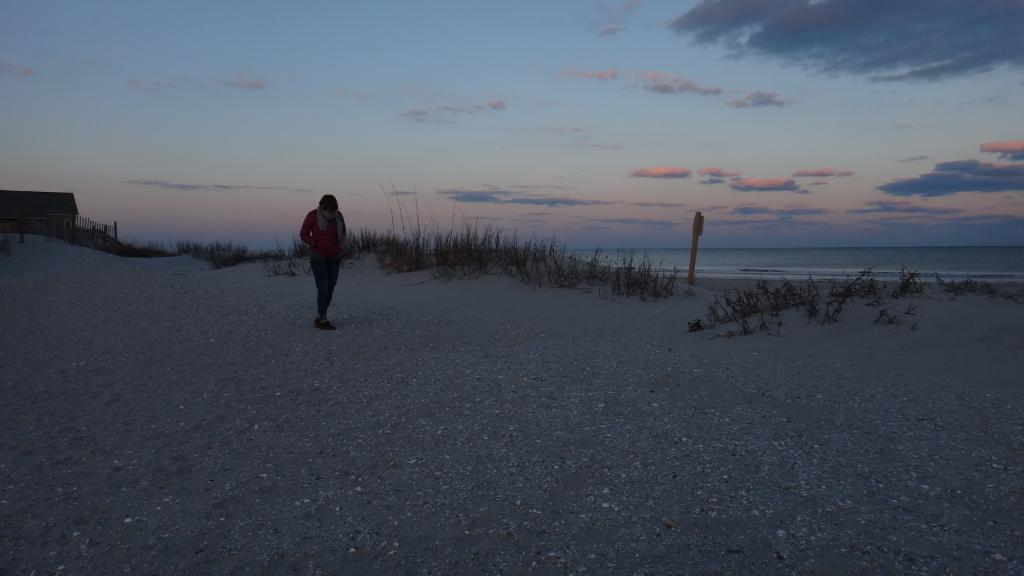What is the main subject of the image? There is a person standing in the image. What type of terrain is visible in the image? There is grass in the image, and it appears to be at the seashore. What type of structure can be seen in the image? There is a house in the image. What else is present in the image besides the person and the house? There is a pole and water visible in the image. What is the condition of the sky in the image? There are clouds in the sky. What year is depicted in the image? The image does not depict a specific year; it is a photograph of a scene at the seashore. What type of space object can be seen in the image? There are no space objects present in the image; it is a photograph of a scene at the seashore. 